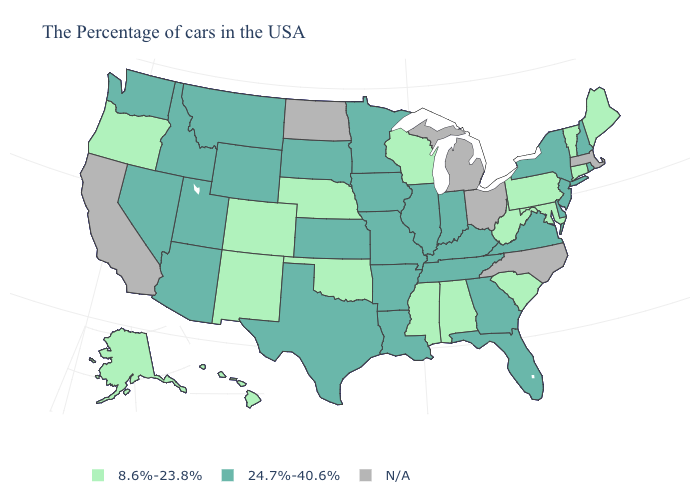Is the legend a continuous bar?
Give a very brief answer. No. Among the states that border Utah , which have the lowest value?
Write a very short answer. Colorado, New Mexico. Does the first symbol in the legend represent the smallest category?
Be succinct. Yes. What is the highest value in states that border Connecticut?
Write a very short answer. 24.7%-40.6%. Which states have the lowest value in the West?
Be succinct. Colorado, New Mexico, Oregon, Alaska, Hawaii. Among the states that border Kansas , does Missouri have the lowest value?
Answer briefly. No. Which states have the lowest value in the South?
Concise answer only. Maryland, South Carolina, West Virginia, Alabama, Mississippi, Oklahoma. What is the value of Hawaii?
Be succinct. 8.6%-23.8%. What is the value of Minnesota?
Answer briefly. 24.7%-40.6%. What is the value of New Hampshire?
Keep it brief. 24.7%-40.6%. What is the value of Virginia?
Quick response, please. 24.7%-40.6%. Name the states that have a value in the range 8.6%-23.8%?
Short answer required. Maine, Vermont, Connecticut, Maryland, Pennsylvania, South Carolina, West Virginia, Alabama, Wisconsin, Mississippi, Nebraska, Oklahoma, Colorado, New Mexico, Oregon, Alaska, Hawaii. What is the value of New Jersey?
Concise answer only. 24.7%-40.6%. What is the value of Oklahoma?
Give a very brief answer. 8.6%-23.8%. 